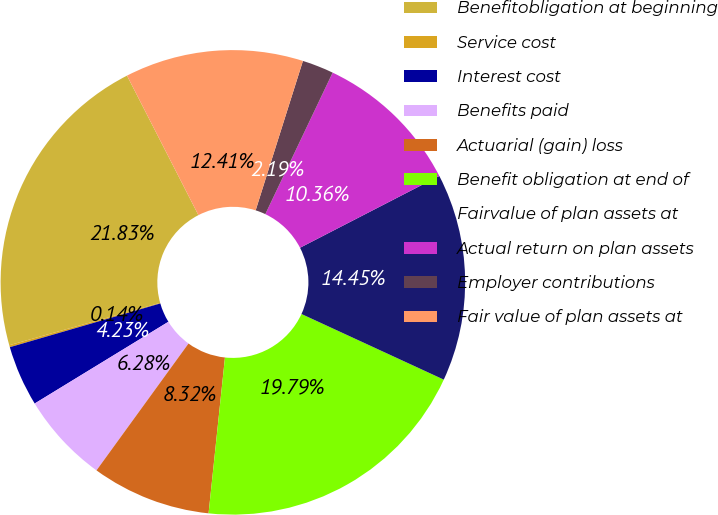<chart> <loc_0><loc_0><loc_500><loc_500><pie_chart><fcel>Benefitobligation at beginning<fcel>Service cost<fcel>Interest cost<fcel>Benefits paid<fcel>Actuarial (gain) loss<fcel>Benefit obligation at end of<fcel>Fairvalue of plan assets at<fcel>Actual return on plan assets<fcel>Employer contributions<fcel>Fair value of plan assets at<nl><fcel>21.83%<fcel>0.14%<fcel>4.23%<fcel>6.28%<fcel>8.32%<fcel>19.79%<fcel>14.45%<fcel>10.36%<fcel>2.19%<fcel>12.41%<nl></chart> 